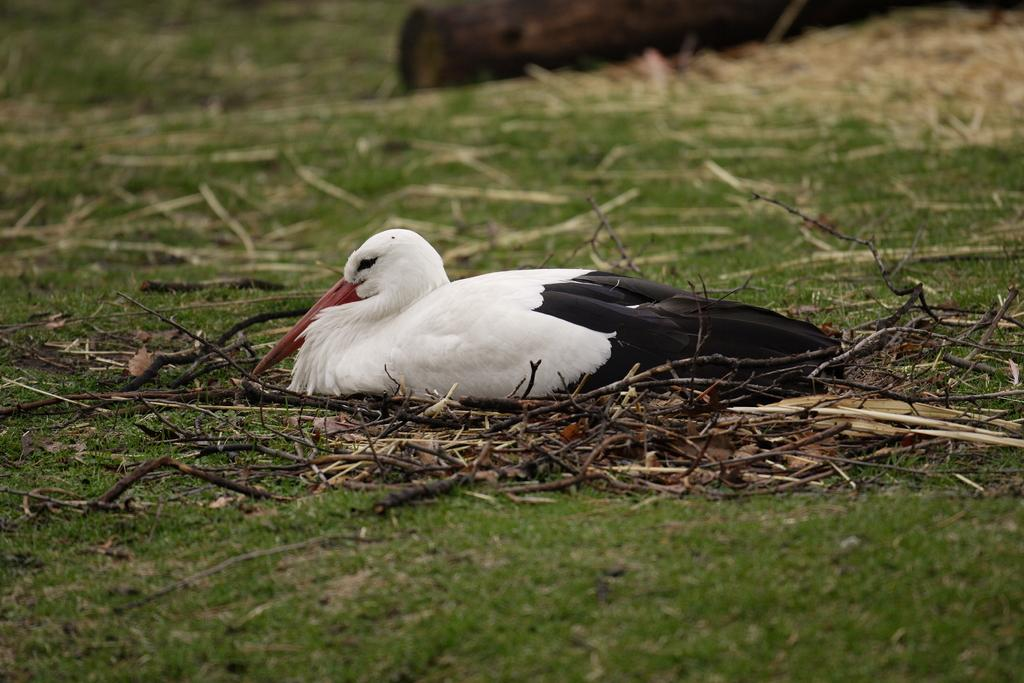What type of animal can be seen in the image? There is a bird in the image. What is the bird standing on? The bird is on sticks. What type of vegetation is visible at the bottom of the image? There is grass visible at the bottom of the image. How is the grass situated in the image? The grass is on the surface. What type of crook is the bird using to reach into the pocket in the image? There is no crook or pocket present in the image; it features a bird standing on sticks with grass at the bottom. 